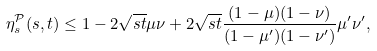<formula> <loc_0><loc_0><loc_500><loc_500>\eta _ { s } ^ { \mathcal { P } } ( s , t ) \leq 1 - 2 \sqrt { s t } \mu \nu + 2 \sqrt { s t } \frac { ( 1 - \mu ) ( 1 - \nu ) } { ( 1 - \mu ^ { \prime } ) ( 1 - \nu ^ { \prime } ) } \mu ^ { \prime } \nu ^ { \prime } ,</formula> 